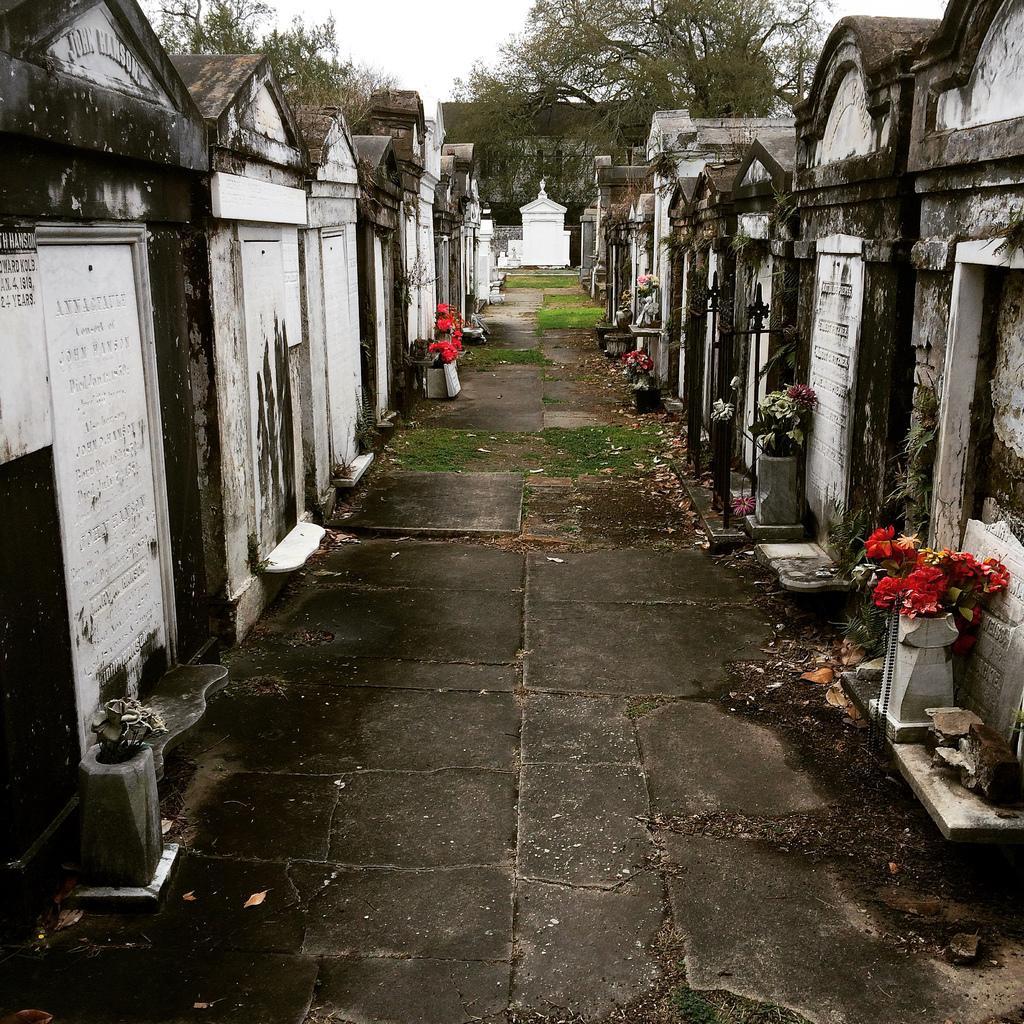Please provide a concise description of this image. In this image we can see graveyard. Also there is text on the graves. And we can see flower bouquets. In the background there are trees and sky. 